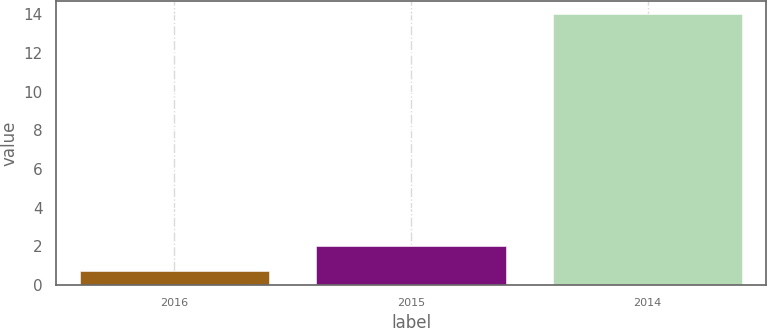Convert chart. <chart><loc_0><loc_0><loc_500><loc_500><bar_chart><fcel>2016<fcel>2015<fcel>2014<nl><fcel>0.7<fcel>2.03<fcel>14<nl></chart> 